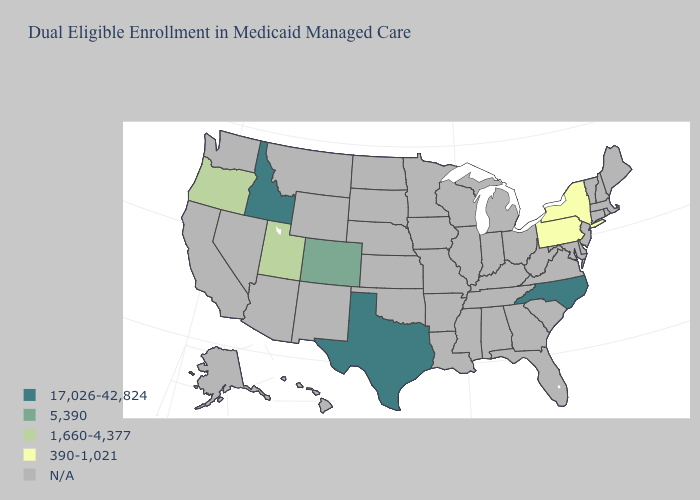What is the lowest value in the USA?
Be succinct. 390-1,021. What is the value of Arkansas?
Write a very short answer. N/A. Does Pennsylvania have the lowest value in the USA?
Answer briefly. Yes. What is the highest value in the Northeast ?
Write a very short answer. 390-1,021. Name the states that have a value in the range 1,660-4,377?
Short answer required. Oregon, Utah. What is the value of Connecticut?
Quick response, please. N/A. Does Texas have the lowest value in the USA?
Quick response, please. No. Which states have the lowest value in the South?
Concise answer only. North Carolina, Texas. What is the value of Arkansas?
Write a very short answer. N/A. Name the states that have a value in the range 1,660-4,377?
Concise answer only. Oregon, Utah. 